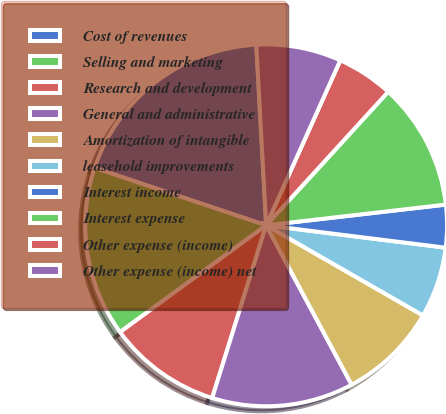Convert chart to OTSL. <chart><loc_0><loc_0><loc_500><loc_500><pie_chart><fcel>Cost of revenues<fcel>Selling and marketing<fcel>Research and development<fcel>General and administrative<fcel>Amortization of intangible<fcel>leasehold improvements<fcel>Interest income<fcel>Interest expense<fcel>Other expense (income)<fcel>Other expense (income) net<nl><fcel>18.99%<fcel>15.19%<fcel>10.13%<fcel>12.66%<fcel>8.86%<fcel>6.33%<fcel>3.8%<fcel>11.39%<fcel>5.06%<fcel>7.59%<nl></chart> 